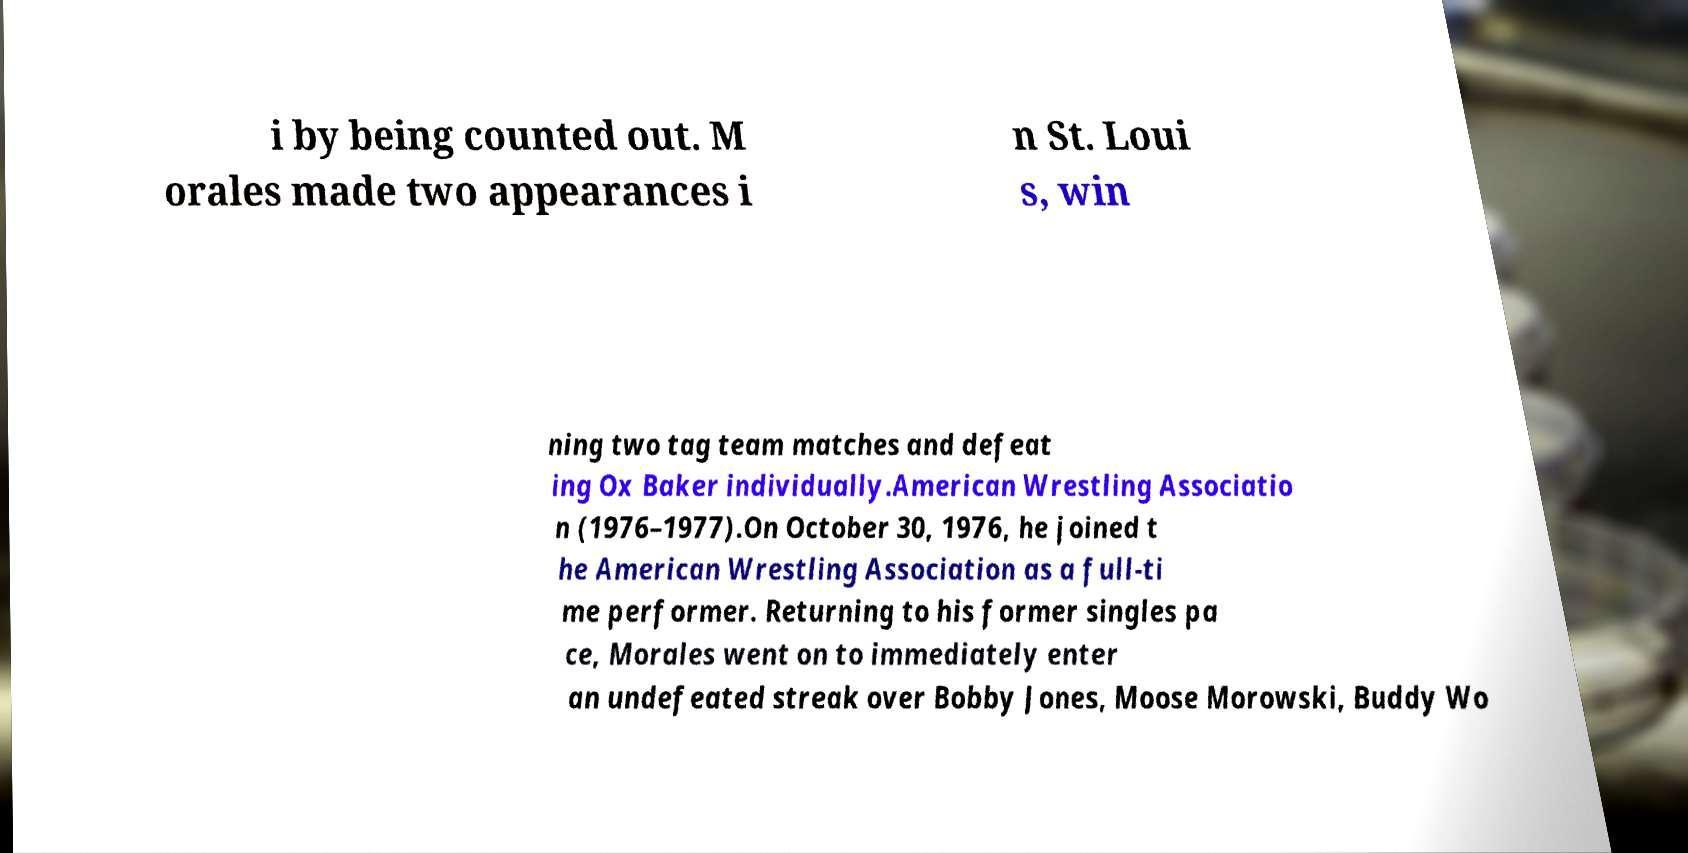Could you assist in decoding the text presented in this image and type it out clearly? i by being counted out. M orales made two appearances i n St. Loui s, win ning two tag team matches and defeat ing Ox Baker individually.American Wrestling Associatio n (1976–1977).On October 30, 1976, he joined t he American Wrestling Association as a full-ti me performer. Returning to his former singles pa ce, Morales went on to immediately enter an undefeated streak over Bobby Jones, Moose Morowski, Buddy Wo 